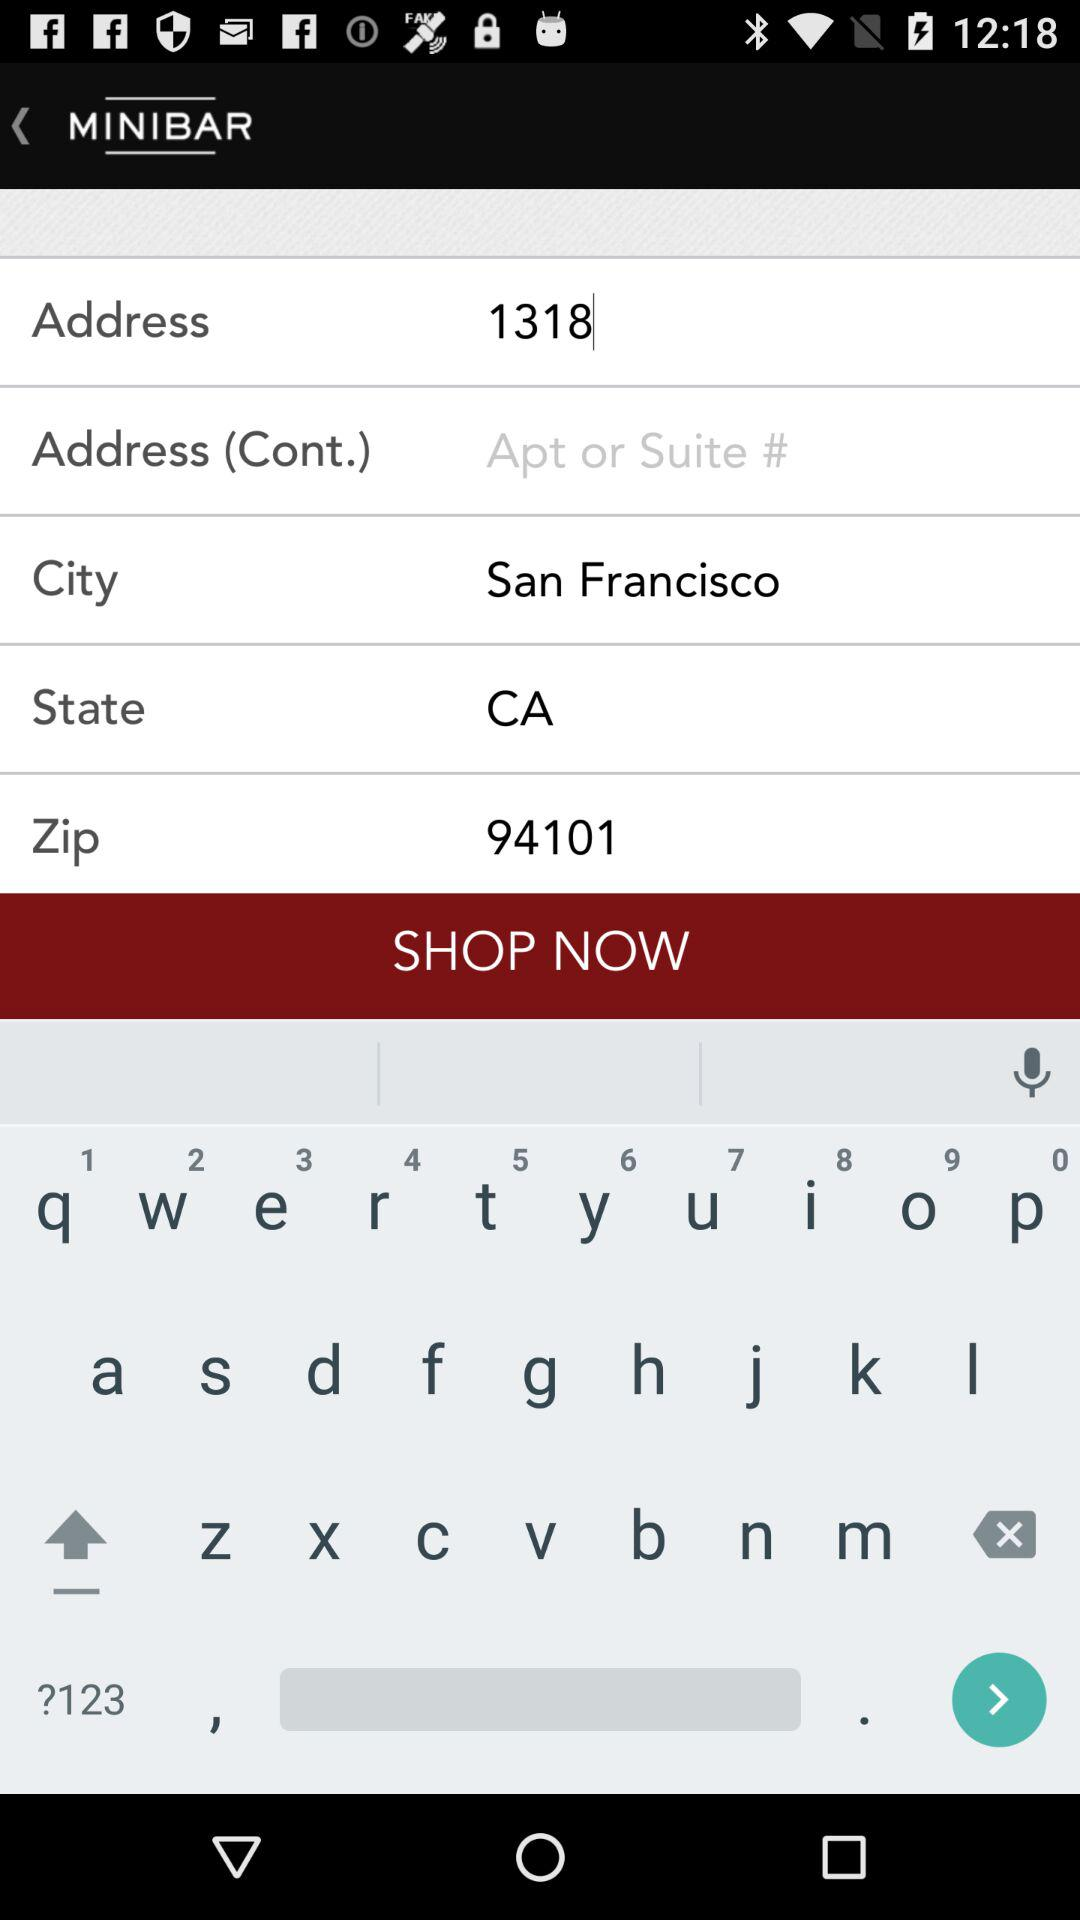What is the current Location?
When the provided information is insufficient, respond with <no answer>. <no answer> 